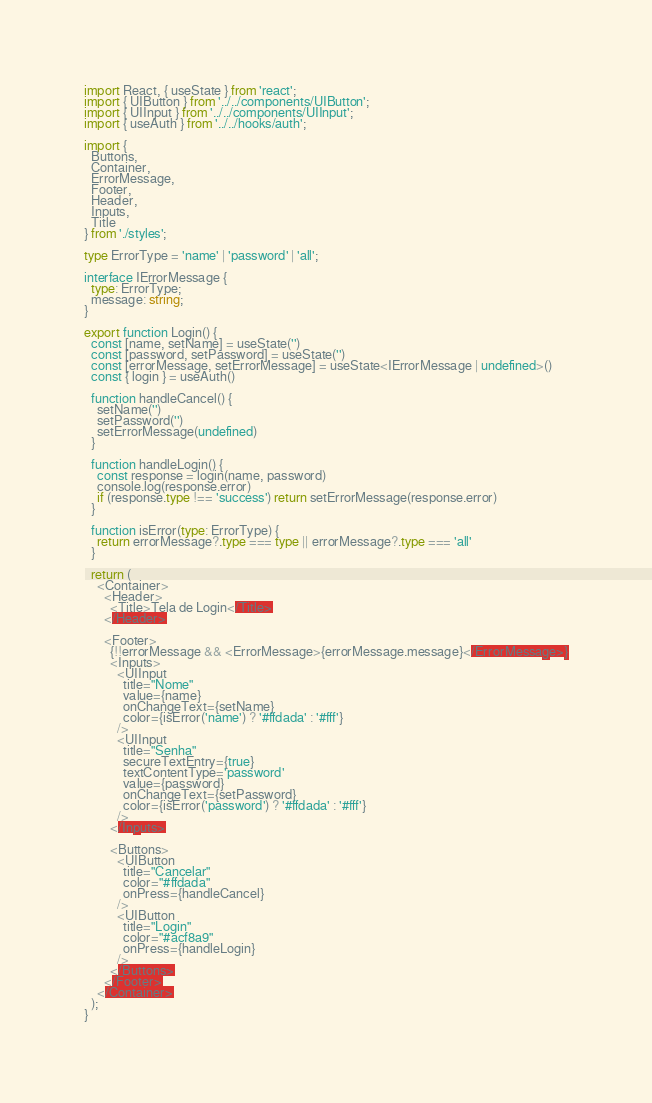<code> <loc_0><loc_0><loc_500><loc_500><_TypeScript_>import React, { useState } from 'react';
import { UIButton } from '../../components/UIButton';
import { UIInput } from '../../components/UIInput';
import { useAuth } from '../../hooks/auth';

import {
  Buttons,
  Container,
  ErrorMessage,
  Footer,
  Header,
  Inputs,
  Title
} from './styles';

type ErrorType = 'name' | 'password' | 'all';

interface IErrorMessage {
  type: ErrorType;
  message: string;
}

export function Login() {
  const [name, setName] = useState('')
  const [password, setPassword] = useState('')
  const [errorMessage, setErrorMessage] = useState<IErrorMessage | undefined>()
  const { login } = useAuth()

  function handleCancel() {
    setName('')
    setPassword('')
    setErrorMessage(undefined)
  }

  function handleLogin() {
    const response = login(name, password)
    console.log(response.error)
    if (response.type !== 'success') return setErrorMessage(response.error)
  }

  function isError(type: ErrorType) {
    return errorMessage?.type === type || errorMessage?.type === 'all'
  }

  return (
    <Container>
      <Header>
        <Title>Tela de Login</Title>
      </Header>

      <Footer>
        {!!errorMessage && <ErrorMessage>{errorMessage.message}</ErrorMessage>}
        <Inputs>
          <UIInput
            title="Nome"
            value={name}
            onChangeText={setName}
            color={isError('name') ? '#ffdada' : '#fff'}
          />
          <UIInput
            title="Senha"
            secureTextEntry={true}
            textContentType='password'
            value={password}
            onChangeText={setPassword}
            color={isError('password') ? '#ffdada' : '#fff'}
          />
        </Inputs>

        <Buttons>
          <UIButton
            title="Cancelar"
            color="#ffdada"
            onPress={handleCancel}
          />
          <UIButton
            title="Login"
            color="#acf8a9"
            onPress={handleLogin}
          />
        </Buttons>
      </Footer>
    </Container>
  );
}
</code> 